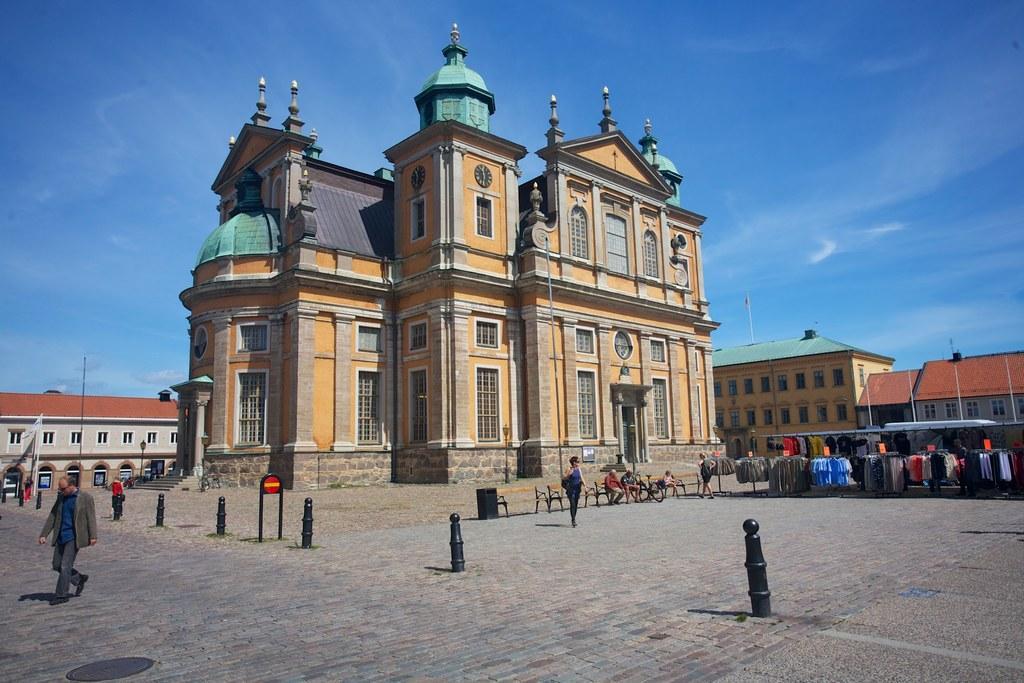Describe this image in one or two sentences. In this image there are few people walking on the road and there are a few people sitting on the chairs. There are poles. On the right side of the image there are tents. There are clothes hanged to the metal rods. On the left side of the image there is a flag. In the background of the image there are buildings, light poles and sky. 